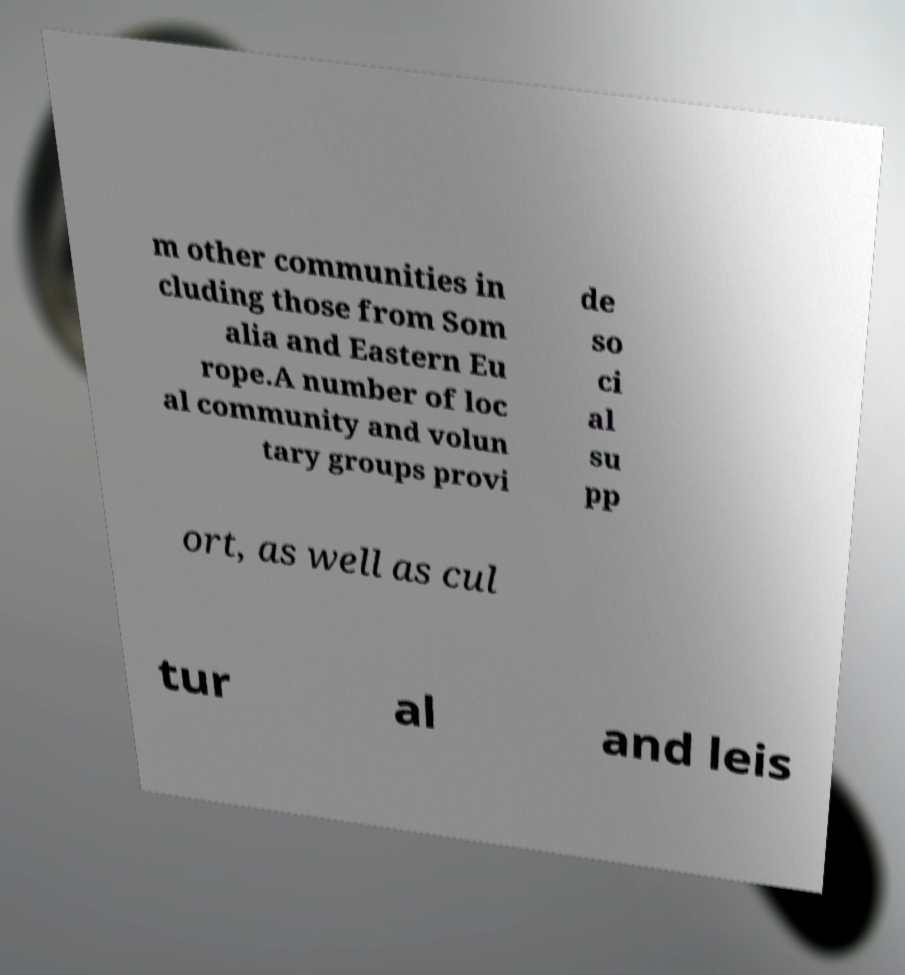For documentation purposes, I need the text within this image transcribed. Could you provide that? m other communities in cluding those from Som alia and Eastern Eu rope.A number of loc al community and volun tary groups provi de so ci al su pp ort, as well as cul tur al and leis 